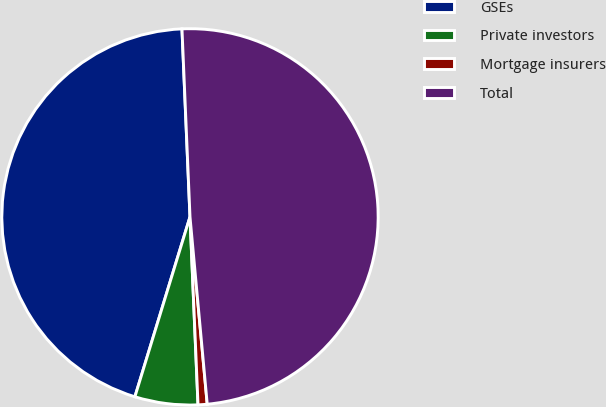<chart> <loc_0><loc_0><loc_500><loc_500><pie_chart><fcel>GSEs<fcel>Private investors<fcel>Mortgage insurers<fcel>Total<nl><fcel>44.59%<fcel>5.41%<fcel>0.78%<fcel>49.22%<nl></chart> 